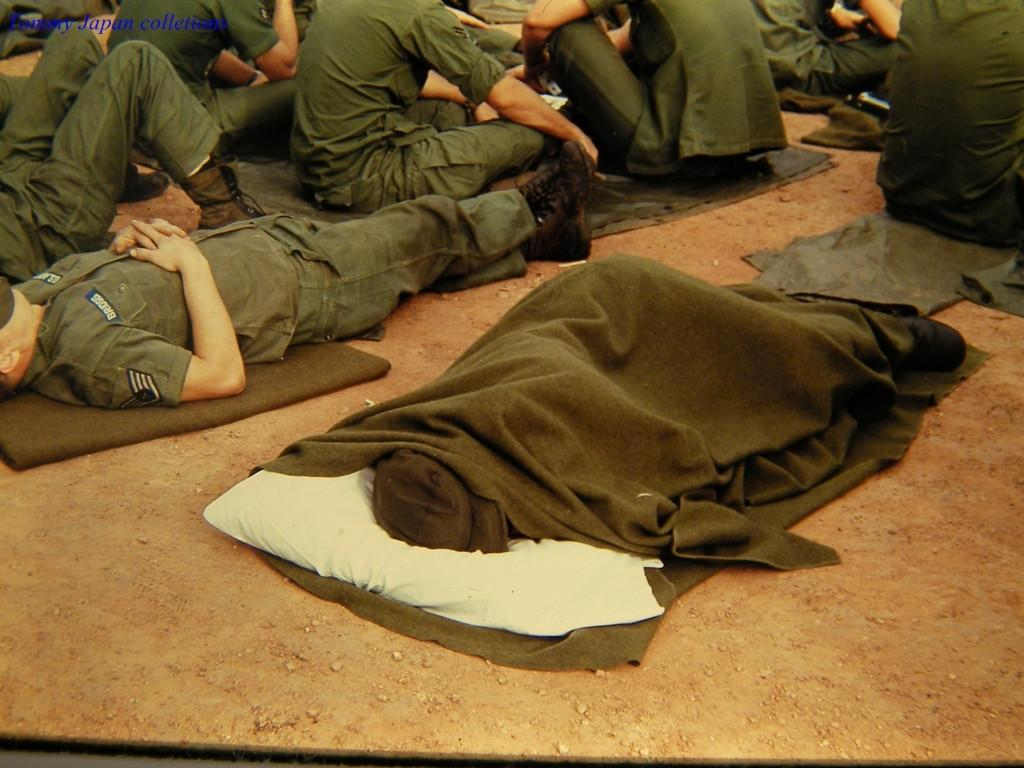What are the people in the image doing? There are people sitting and sleeping on the ground in the image. What might be used to provide warmth or comfort in the image? Blankets are present in the image. What color are the dresses worn by the people in the image? The people are wearing green-colored dresses. What type of story is being told by the light in the image? There is no light present in the image, and therefore no story can be told by it. 